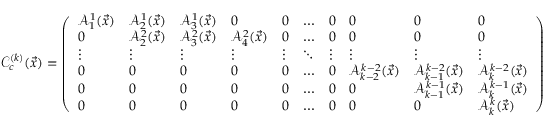<formula> <loc_0><loc_0><loc_500><loc_500>\mathcal { C } _ { c } ^ { ( k ) } ( \vec { x } ) = \left ( \begin{array} { l l l l l l l l l l } { \mathcal { A } _ { 1 } ^ { 1 } ( \vec { x } ) } & { \mathcal { A } _ { 2 } ^ { 1 } ( \vec { x } ) } & { \mathcal { A } _ { 3 } ^ { 1 } ( \vec { x } ) } & { 0 } & { 0 } & { \dots } & { 0 } & { 0 } & { 0 } & { 0 } \\ { 0 } & { \mathcal { A } _ { 2 } ^ { 2 } ( \vec { x } ) } & { \mathcal { A } _ { 3 } ^ { 2 } ( \vec { x } ) } & { \mathcal { A } _ { 4 } ^ { 2 } ( \vec { x } ) } & { 0 } & { \dots } & { 0 } & { 0 } & { 0 } & { 0 } \\ { \vdots } & { \vdots } & { \vdots } & { \vdots } & { \vdots } & { \ddots } & { \vdots } & { \vdots } & { \vdots } & { \vdots } \\ { 0 } & { 0 } & { 0 } & { 0 } & { 0 } & { \dots } & { 0 } & { \mathcal { A } _ { k - 2 } ^ { k - 2 } ( \vec { x } ) } & { \mathcal { A } _ { k - 1 } ^ { k - 2 } ( \vec { x } ) } & { \mathcal { A } _ { k } ^ { k - 2 } ( \vec { x } ) } \\ { 0 } & { 0 } & { 0 } & { 0 } & { 0 } & { \dots } & { 0 } & { 0 } & { \mathcal { A } _ { k - 1 } ^ { k - 1 } ( \vec { x } ) } & { \mathcal { A } _ { k } ^ { k - 1 } ( \vec { x } ) } \\ { 0 } & { 0 } & { 0 } & { 0 } & { 0 } & { \dots } & { 0 } & { 0 } & { 0 } & { \mathcal { A } _ { k } ^ { k } ( \vec { x } ) } \end{array} \right )</formula> 